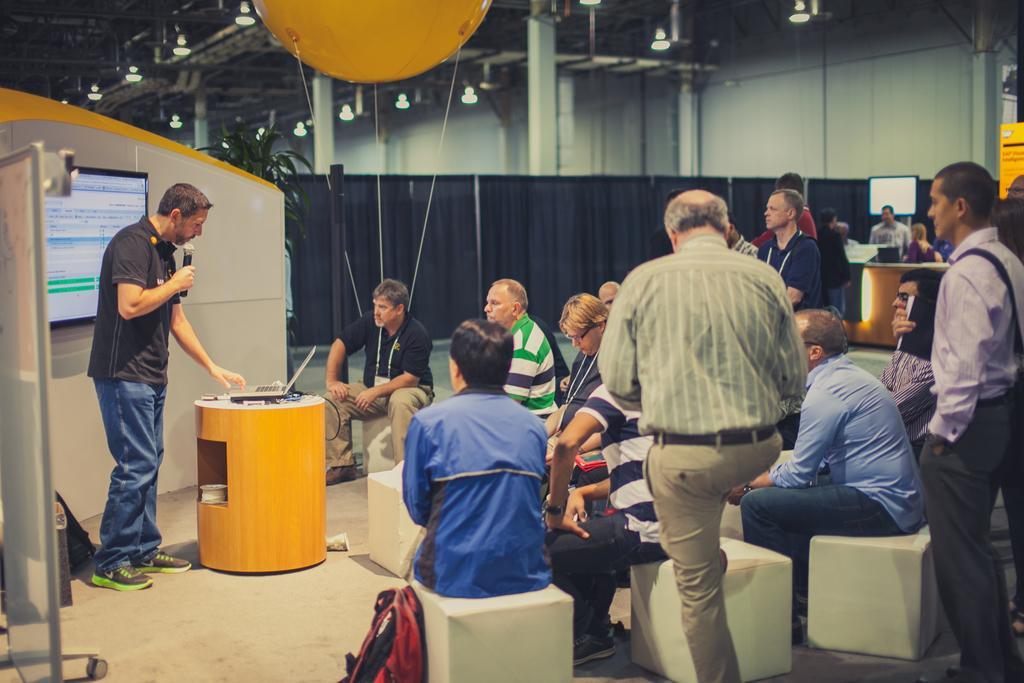Could you give a brief overview of what you see in this image? In this image there is a person standing and holding a mic is speaking, in front of the person on the table there is a laptop with cables, behind the person there is a tv and there is a board, in front of the person there are a few people seated and there are a few people standing. On the other side of the image there is a partition, beside the partition there are a few people standing in front of a counter, on the counter there is a person with a laptop in front of him, behind the person there is a television, at the top of the image there are lamps hanging from the ceiling and there is a gas balloon. 